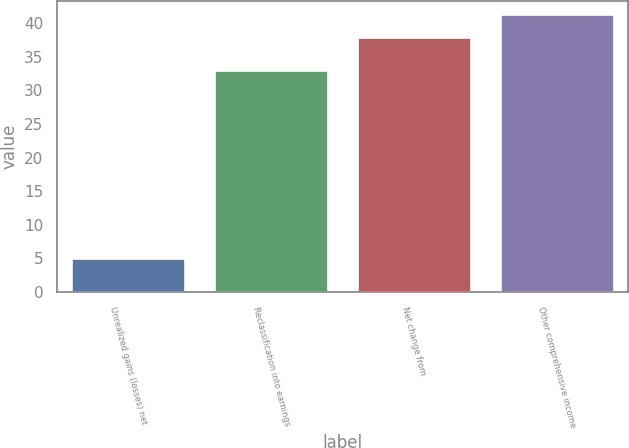<chart> <loc_0><loc_0><loc_500><loc_500><bar_chart><fcel>Unrealized gains (losses) net<fcel>Reclassification into earnings<fcel>Net change from<fcel>Other comprehensive income<nl><fcel>5<fcel>33<fcel>38<fcel>41.3<nl></chart> 